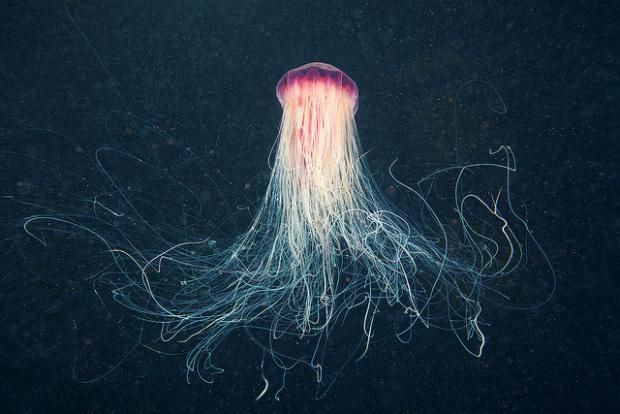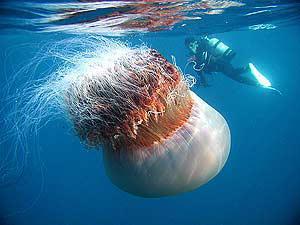The first image is the image on the left, the second image is the image on the right. Given the left and right images, does the statement "The sea creature in the image on the right looks like a cross between a clownfish and a jellyfish, with its bright orange body and white blotches." hold true? Answer yes or no. No. The first image is the image on the left, the second image is the image on the right. Evaluate the accuracy of this statement regarding the images: "At least one image shows a jellyfish with a folded appearance and no tendrils trailing from it.". Is it true? Answer yes or no. No. 